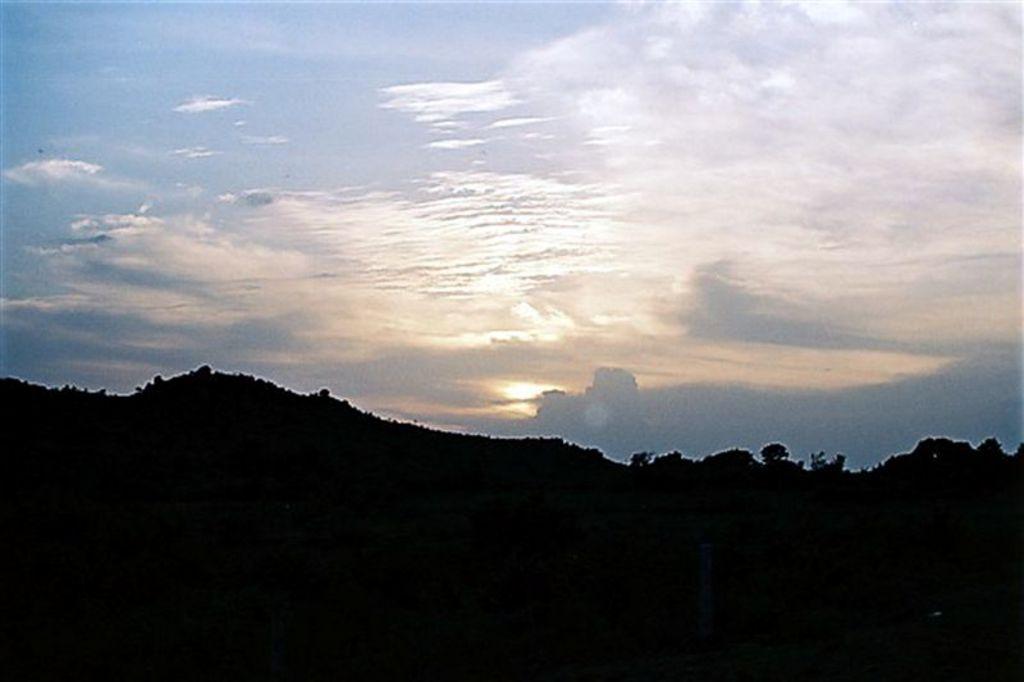How would you summarize this image in a sentence or two? In the image there are hills in the back with trees all over it and above its sky with clouds. 